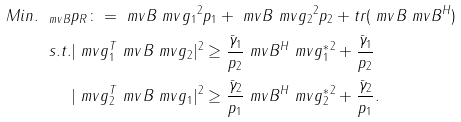Convert formula to latex. <formula><loc_0><loc_0><loc_500><loc_500>M i n . _ { \ m v { B } } & p _ { R } \colon = \| \ m v { B } \ m v { g } _ { 1 } \| ^ { 2 } p _ { 1 } + \| \ m v { B } \ m v { g } _ { 2 } \| ^ { 2 } p _ { 2 } + t r ( \ m v { B } \ m v { B } ^ { H } ) \\ s . t . & | \ m v { g } _ { 1 } ^ { T } \ m v { B } \ m v { g } _ { 2 } | ^ { 2 } \geq \frac { \bar { \gamma } _ { 1 } } { p _ { 2 } } \| \ m v { B } ^ { H } \ m v { g } _ { 1 } ^ { * } \| ^ { 2 } + \frac { \bar { \gamma } _ { 1 } } { p _ { 2 } } \\ & | \ m v { g } _ { 2 } ^ { T } \ m v { B } \ m v { g } _ { 1 } | ^ { 2 } \geq \frac { \bar { \gamma } _ { 2 } } { p _ { 1 } } \| \ m v { B } ^ { H } \ m v { g } _ { 2 } ^ { * } \| ^ { 2 } + \frac { \bar { \gamma } _ { 2 } } { p _ { 1 } } .</formula> 